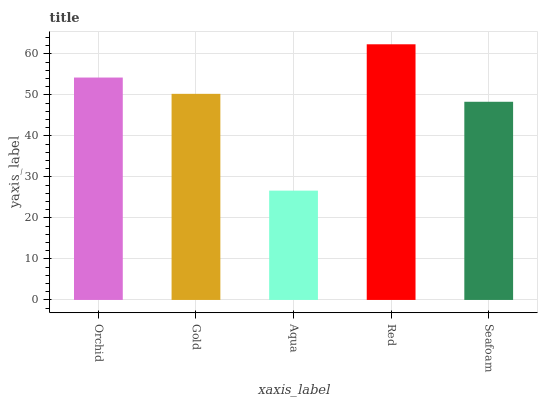Is Gold the minimum?
Answer yes or no. No. Is Gold the maximum?
Answer yes or no. No. Is Orchid greater than Gold?
Answer yes or no. Yes. Is Gold less than Orchid?
Answer yes or no. Yes. Is Gold greater than Orchid?
Answer yes or no. No. Is Orchid less than Gold?
Answer yes or no. No. Is Gold the high median?
Answer yes or no. Yes. Is Gold the low median?
Answer yes or no. Yes. Is Orchid the high median?
Answer yes or no. No. Is Orchid the low median?
Answer yes or no. No. 